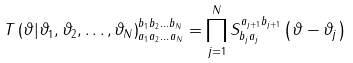Convert formula to latex. <formula><loc_0><loc_0><loc_500><loc_500>T \left ( \vartheta | \vartheta _ { 1 } , \vartheta _ { 2 } , \dots , \vartheta _ { N } \right ) _ { a _ { 1 } a _ { 2 } \dots a _ { N } } ^ { b _ { 1 } b _ { 2 } \dots b _ { N } } = \prod _ { j = 1 } ^ { N } S _ { b _ { j } a _ { j } } ^ { a _ { j + 1 } b _ { j + 1 } } \left ( \vartheta - \vartheta _ { j } \right )</formula> 